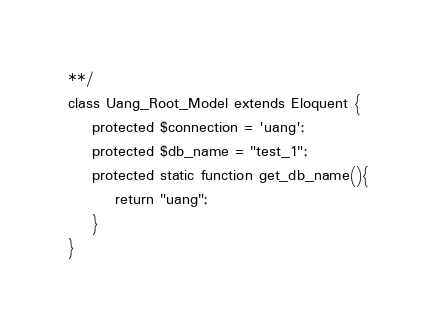Convert code to text. <code><loc_0><loc_0><loc_500><loc_500><_PHP_>**/
class Uang_Root_Model extends Eloquent {
	protected $connection = 'uang';
	protected $db_name = "test_1";
	protected static function get_db_name(){
		return "uang";
	}
}</code> 